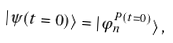<formula> <loc_0><loc_0><loc_500><loc_500>| \psi ( t = 0 ) \rangle = | \varphi _ { n } ^ { P ( t = 0 ) } \rangle \, ,</formula> 